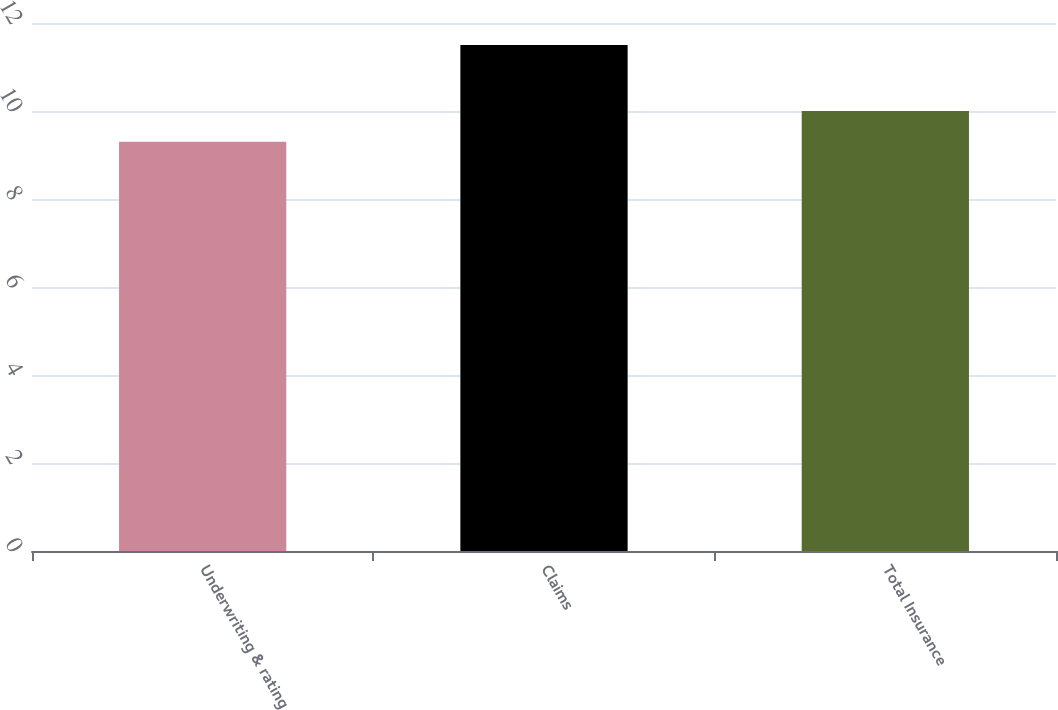<chart> <loc_0><loc_0><loc_500><loc_500><bar_chart><fcel>Underwriting & rating<fcel>Claims<fcel>Total Insurance<nl><fcel>9.3<fcel>11.5<fcel>10<nl></chart> 